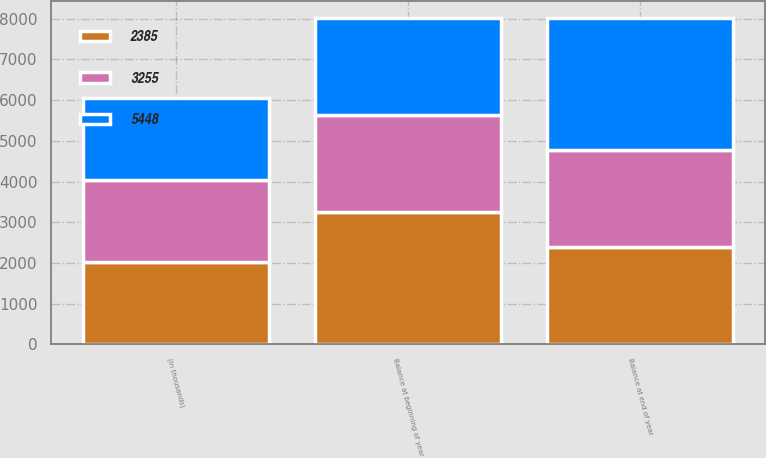Convert chart to OTSL. <chart><loc_0><loc_0><loc_500><loc_500><stacked_bar_chart><ecel><fcel>(In thousands)<fcel>Balance at beginning of year<fcel>Balance at end of year<nl><fcel>2385<fcel>2015<fcel>3255<fcel>2385<nl><fcel>5448<fcel>2014<fcel>2385<fcel>3255<nl><fcel>3255<fcel>2013<fcel>2385<fcel>2385<nl></chart> 